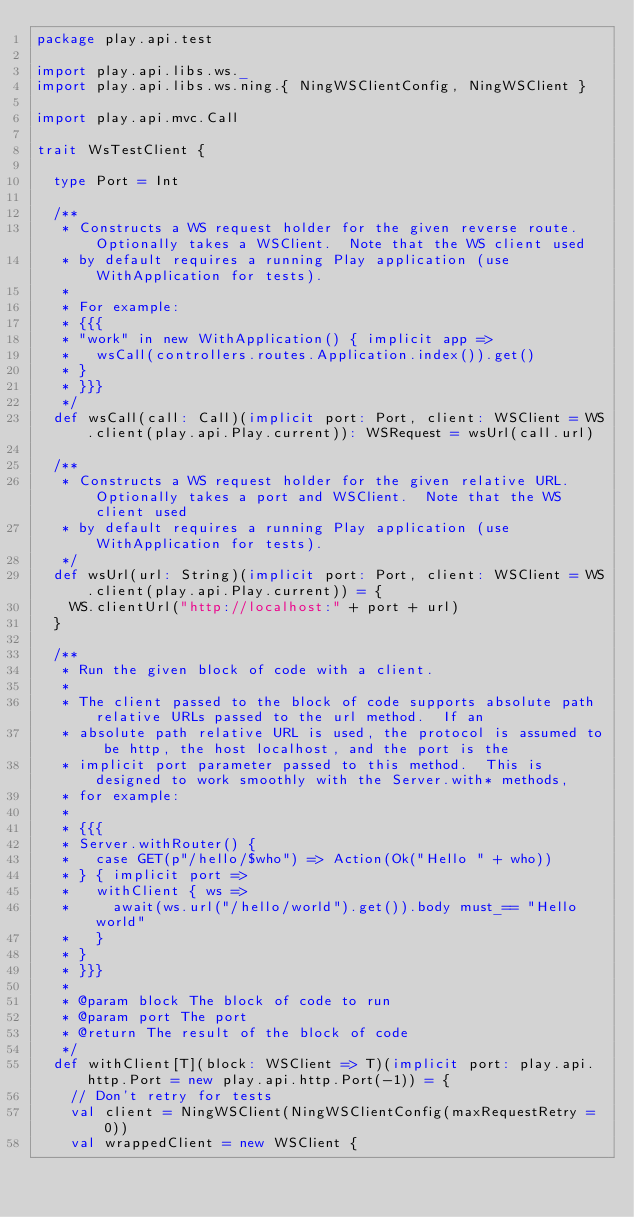<code> <loc_0><loc_0><loc_500><loc_500><_Scala_>package play.api.test

import play.api.libs.ws._
import play.api.libs.ws.ning.{ NingWSClientConfig, NingWSClient }

import play.api.mvc.Call

trait WsTestClient {

  type Port = Int

  /**
   * Constructs a WS request holder for the given reverse route.  Optionally takes a WSClient.  Note that the WS client used
   * by default requires a running Play application (use WithApplication for tests).
   *
   * For example:
   * {{{
   * "work" in new WithApplication() { implicit app =>
   *   wsCall(controllers.routes.Application.index()).get()
   * }
   * }}}
   */
  def wsCall(call: Call)(implicit port: Port, client: WSClient = WS.client(play.api.Play.current)): WSRequest = wsUrl(call.url)

  /**
   * Constructs a WS request holder for the given relative URL.  Optionally takes a port and WSClient.  Note that the WS client used
   * by default requires a running Play application (use WithApplication for tests).
   */
  def wsUrl(url: String)(implicit port: Port, client: WSClient = WS.client(play.api.Play.current)) = {
    WS.clientUrl("http://localhost:" + port + url)
  }

  /**
   * Run the given block of code with a client.
   *
   * The client passed to the block of code supports absolute path relative URLs passed to the url method.  If an
   * absolute path relative URL is used, the protocol is assumed to be http, the host localhost, and the port is the
   * implicit port parameter passed to this method.  This is designed to work smoothly with the Server.with* methods,
   * for example:
   *
   * {{{
   * Server.withRouter() {
   *   case GET(p"/hello/$who") => Action(Ok("Hello " + who))
   * } { implicit port =>
   *   withClient { ws =>
   *     await(ws.url("/hello/world").get()).body must_== "Hello world"
   *   }
   * }
   * }}}
   *
   * @param block The block of code to run
   * @param port The port
   * @return The result of the block of code
   */
  def withClient[T](block: WSClient => T)(implicit port: play.api.http.Port = new play.api.http.Port(-1)) = {
    // Don't retry for tests
    val client = NingWSClient(NingWSClientConfig(maxRequestRetry = 0))
    val wrappedClient = new WSClient {</code> 